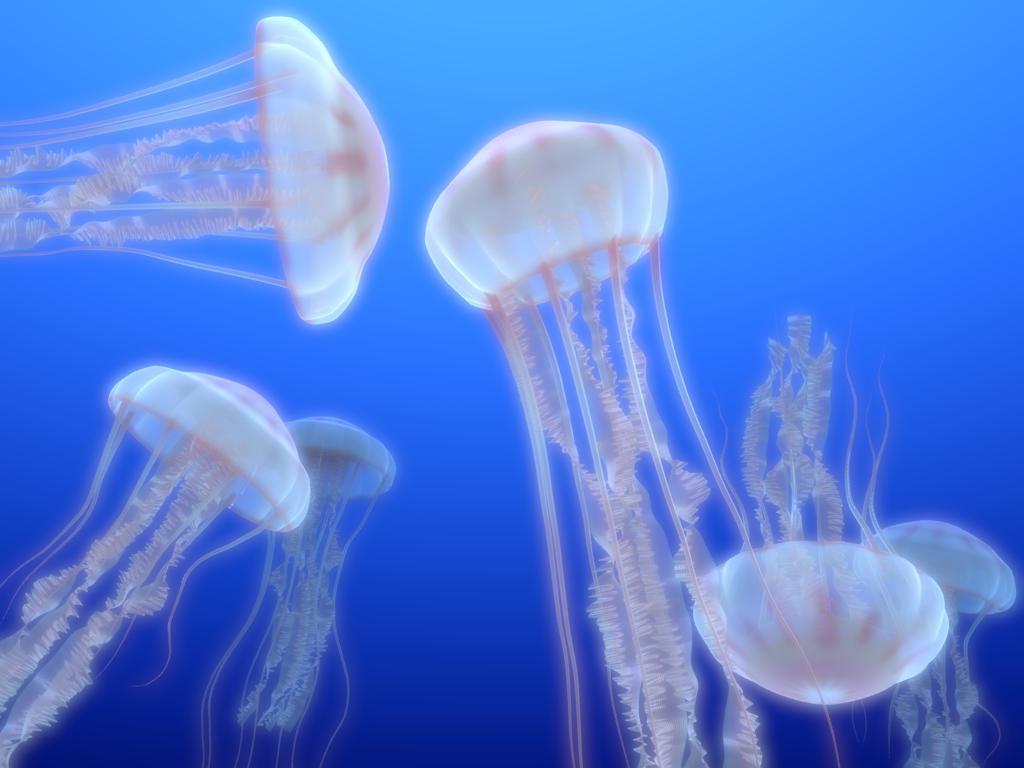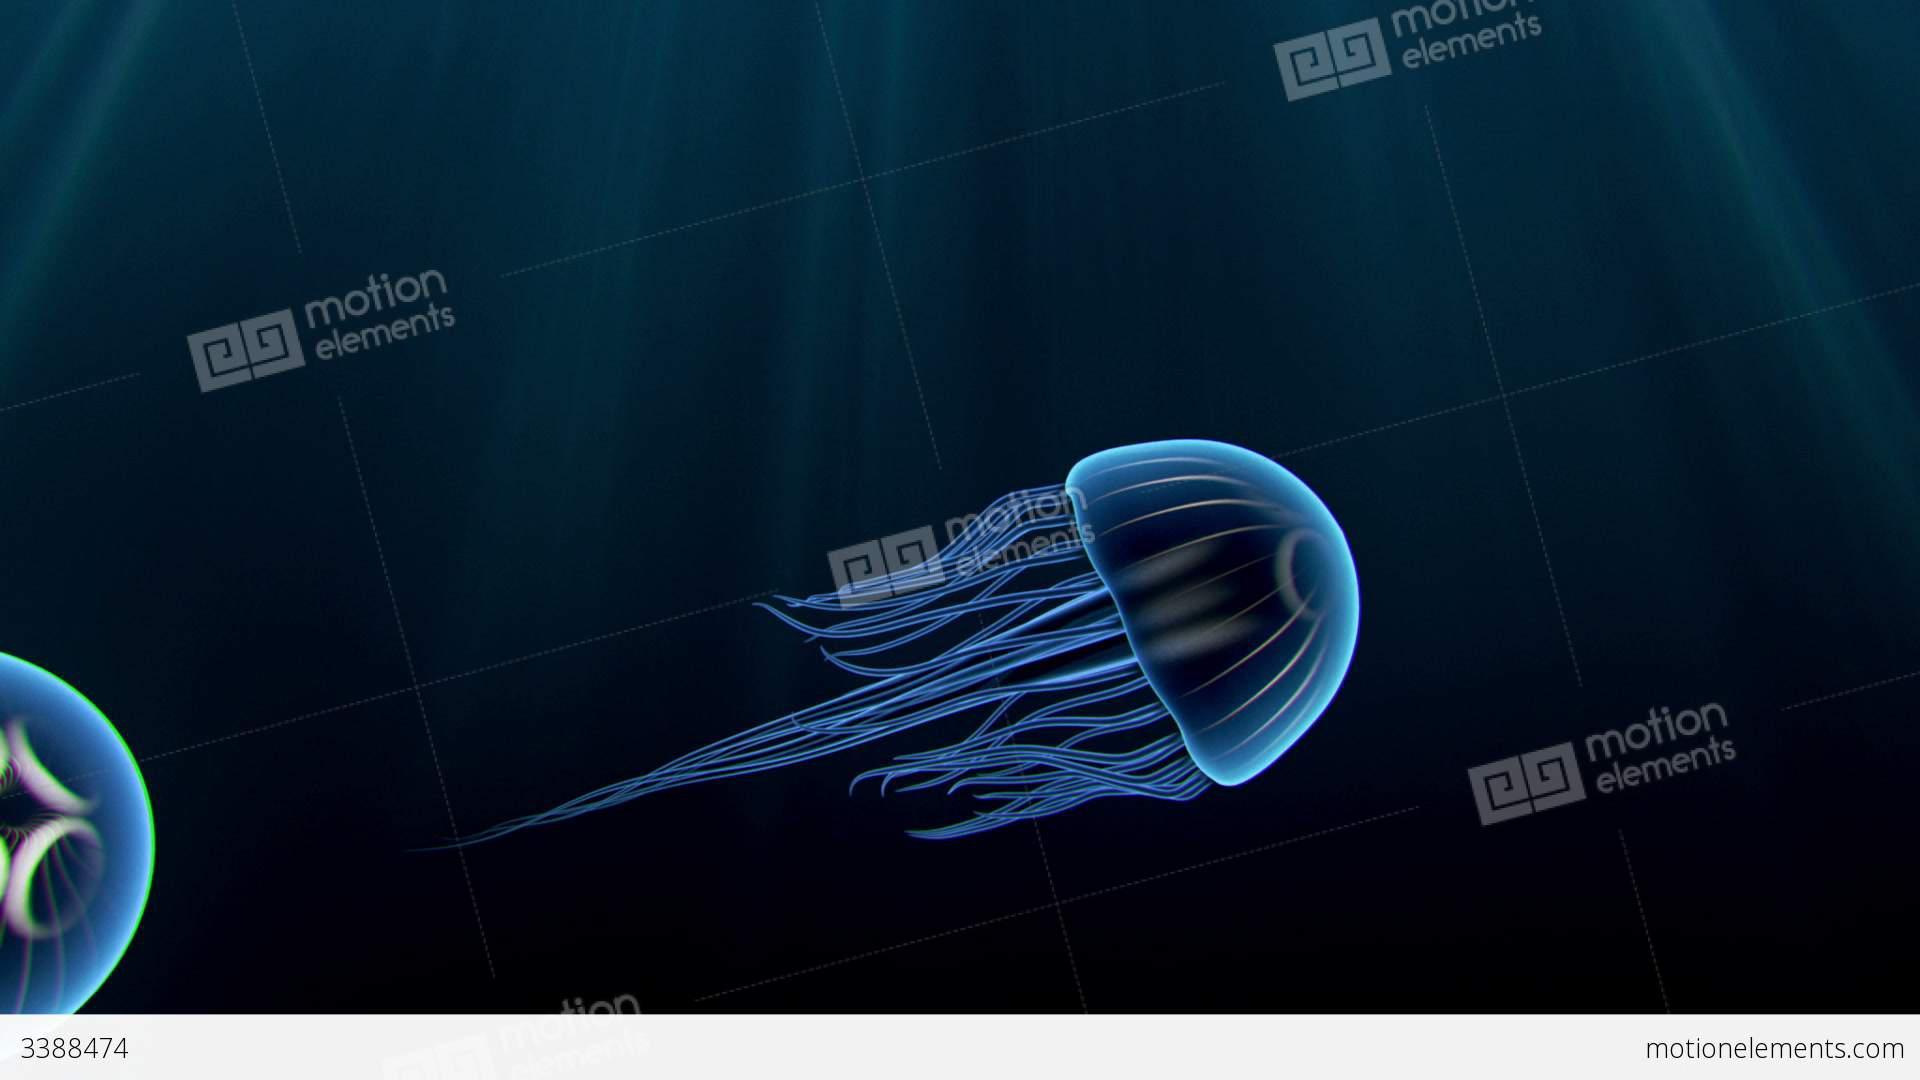The first image is the image on the left, the second image is the image on the right. Given the left and right images, does the statement "There are less than 9 jellyfish." hold true? Answer yes or no. Yes. The first image is the image on the left, the second image is the image on the right. Assess this claim about the two images: "One image features a translucent blue jellyfish moving diagonally to the right, with tentacles trailing behind it.". Correct or not? Answer yes or no. Yes. 